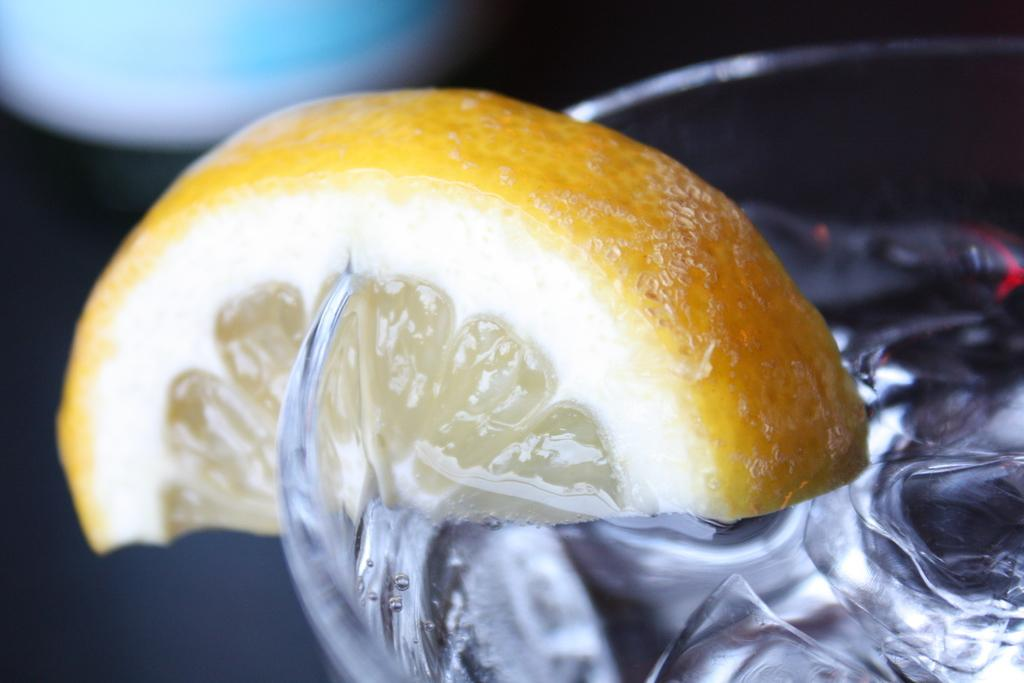What is the main object in the image? There is a slice of lemon in the image. How is the slice of lemon positioned in the image? The slice of lemon is attached to a glass. What else can be seen in the image besides the lemon? There are ice cubes in the image. What type of example does the manager provide in the image? There is no manager or example present in the image; it only features a slice of lemon attached to a glass and ice cubes. 